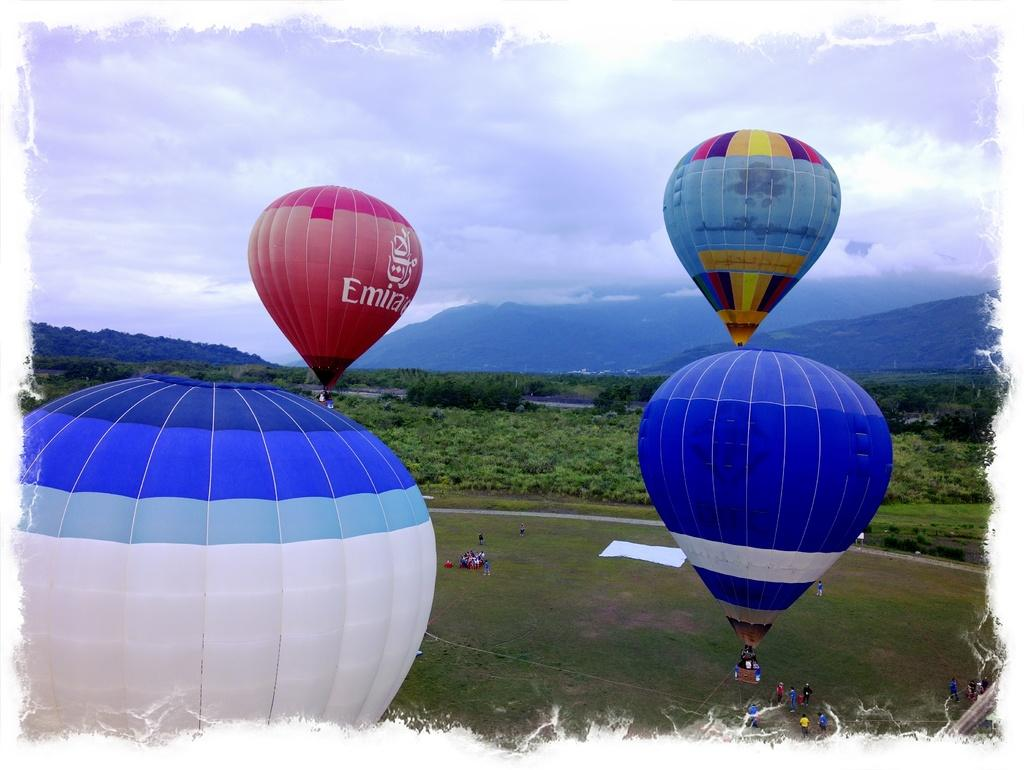What is in the air in the image? There are parachutes in the air. What are the people on the grass doing? The people on the grass are likely observing the parachutes or engaging in a related activity. What can be seen in the background of the image? Trees are visible around the area. How many clams can be seen on the grass in the image? There are no clams present in the image; it features parachutes in the air and people on the grass. What wish is being granted to the people on the grass in the image? There is no indication of a wish being granted in the image; it simply shows parachutes in the air and people on the grass. 